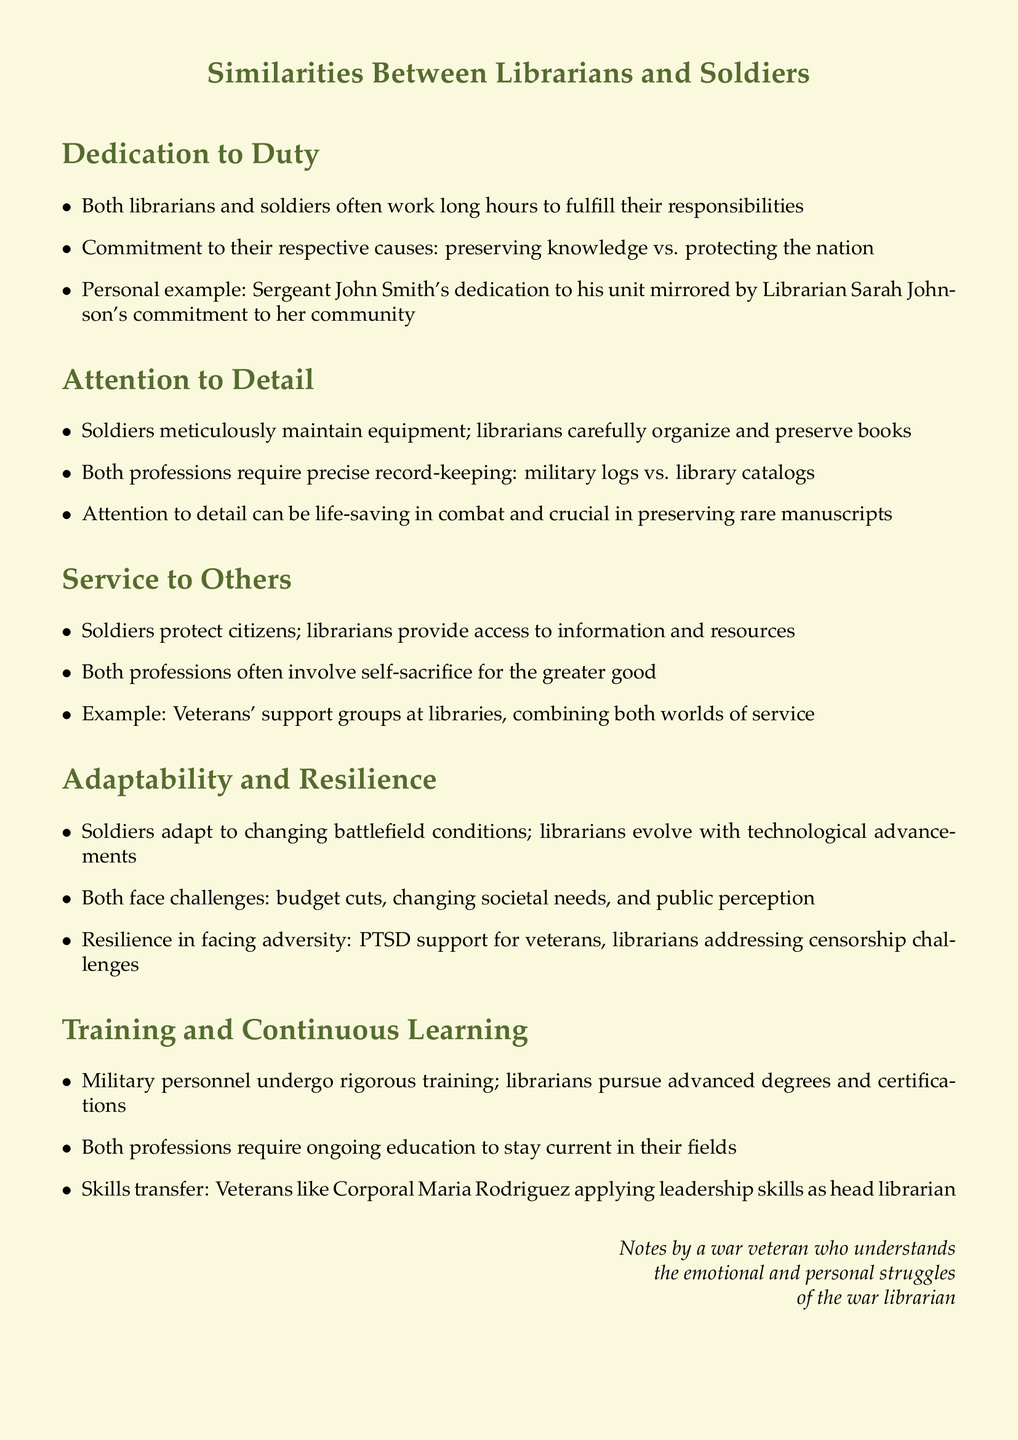What is the title of the document? The title is explicitly stated at the beginning of the document as "Similarities Between Librarians and Soldiers."
Answer: Similarities Between Librarians and Soldiers Who is an example of a soldier mentioned in the document? The document provides a personal example of Sergeant John Smith.
Answer: Sergeant John Smith What is one main characteristic shared by librarians and soldiers? The document highlights several shared characteristics, one being dedication to duty.
Answer: Dedication to duty How do soldiers and librarians demonstrate attention to detail? The document explains that soldiers maintain equipment while librarians organize books, showcasing their focus on detail.
Answer: Maintain equipment; organize books What type of training do military personnel undergo? The document specifies that military personnel undergo rigorous training.
Answer: Rigorous training What do both librarians and soldiers require to stay current in their fields? The document states that both professions require ongoing education.
Answer: Ongoing education How do soldiers provide service to the community according to the document? The document mentions that soldiers protect citizens, showing their service to the community.
Answer: Protect citizens What challenges do soldiers and librarians face according to the notes? The document lists challenges such as budget cuts and changing societal needs that both professions encounter.
Answer: Budget cuts; changing societal needs What is a key aspect of adaptability mentioned in the document? It is noted that soldiers adapt to changing battlefield conditions, which emphasizes their adaptability.
Answer: Changing battlefield conditions 